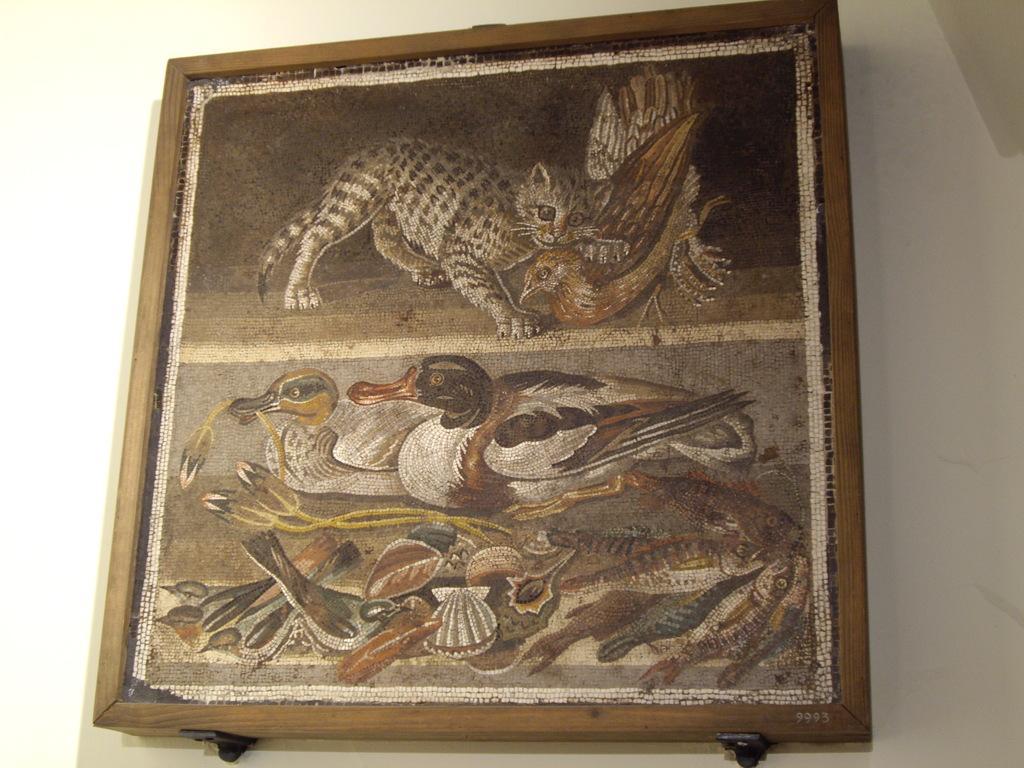Could you give a brief overview of what you see in this image? In this picture we can see a photo frame, there is a picture of ducks and a cat in the frame, in the background there is a wall. 